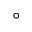<formula> <loc_0><loc_0><loc_500><loc_500>\circ</formula> 